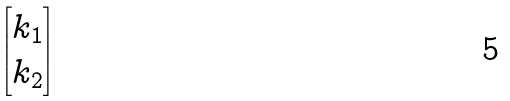Convert formula to latex. <formula><loc_0><loc_0><loc_500><loc_500>\begin{bmatrix} k _ { 1 } \\ k _ { 2 } \end{bmatrix}</formula> 